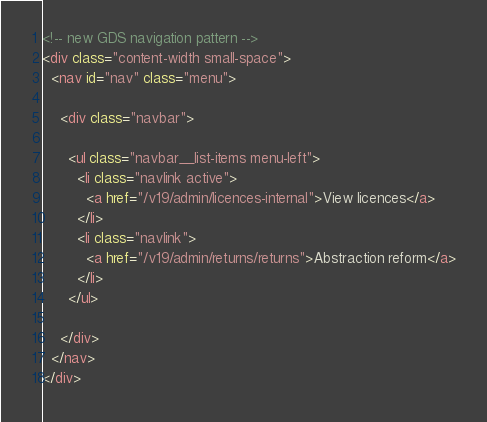Convert code to text. <code><loc_0><loc_0><loc_500><loc_500><_HTML_><!-- new GDS navigation pattern -->
<div class="content-width small-space">
  <nav id="nav" class="menu">

    <div class="navbar">

      <ul class="navbar__list-items menu-left">
        <li class="navlink active">
          <a href="/v19/admin/licences-internal">View licences</a>
        </li>
        <li class="navlink">
          <a href="/v19/admin/returns/returns">Abstraction reform</a>
        </li>
      </ul>

    </div>
  </nav>
</div>
</code> 